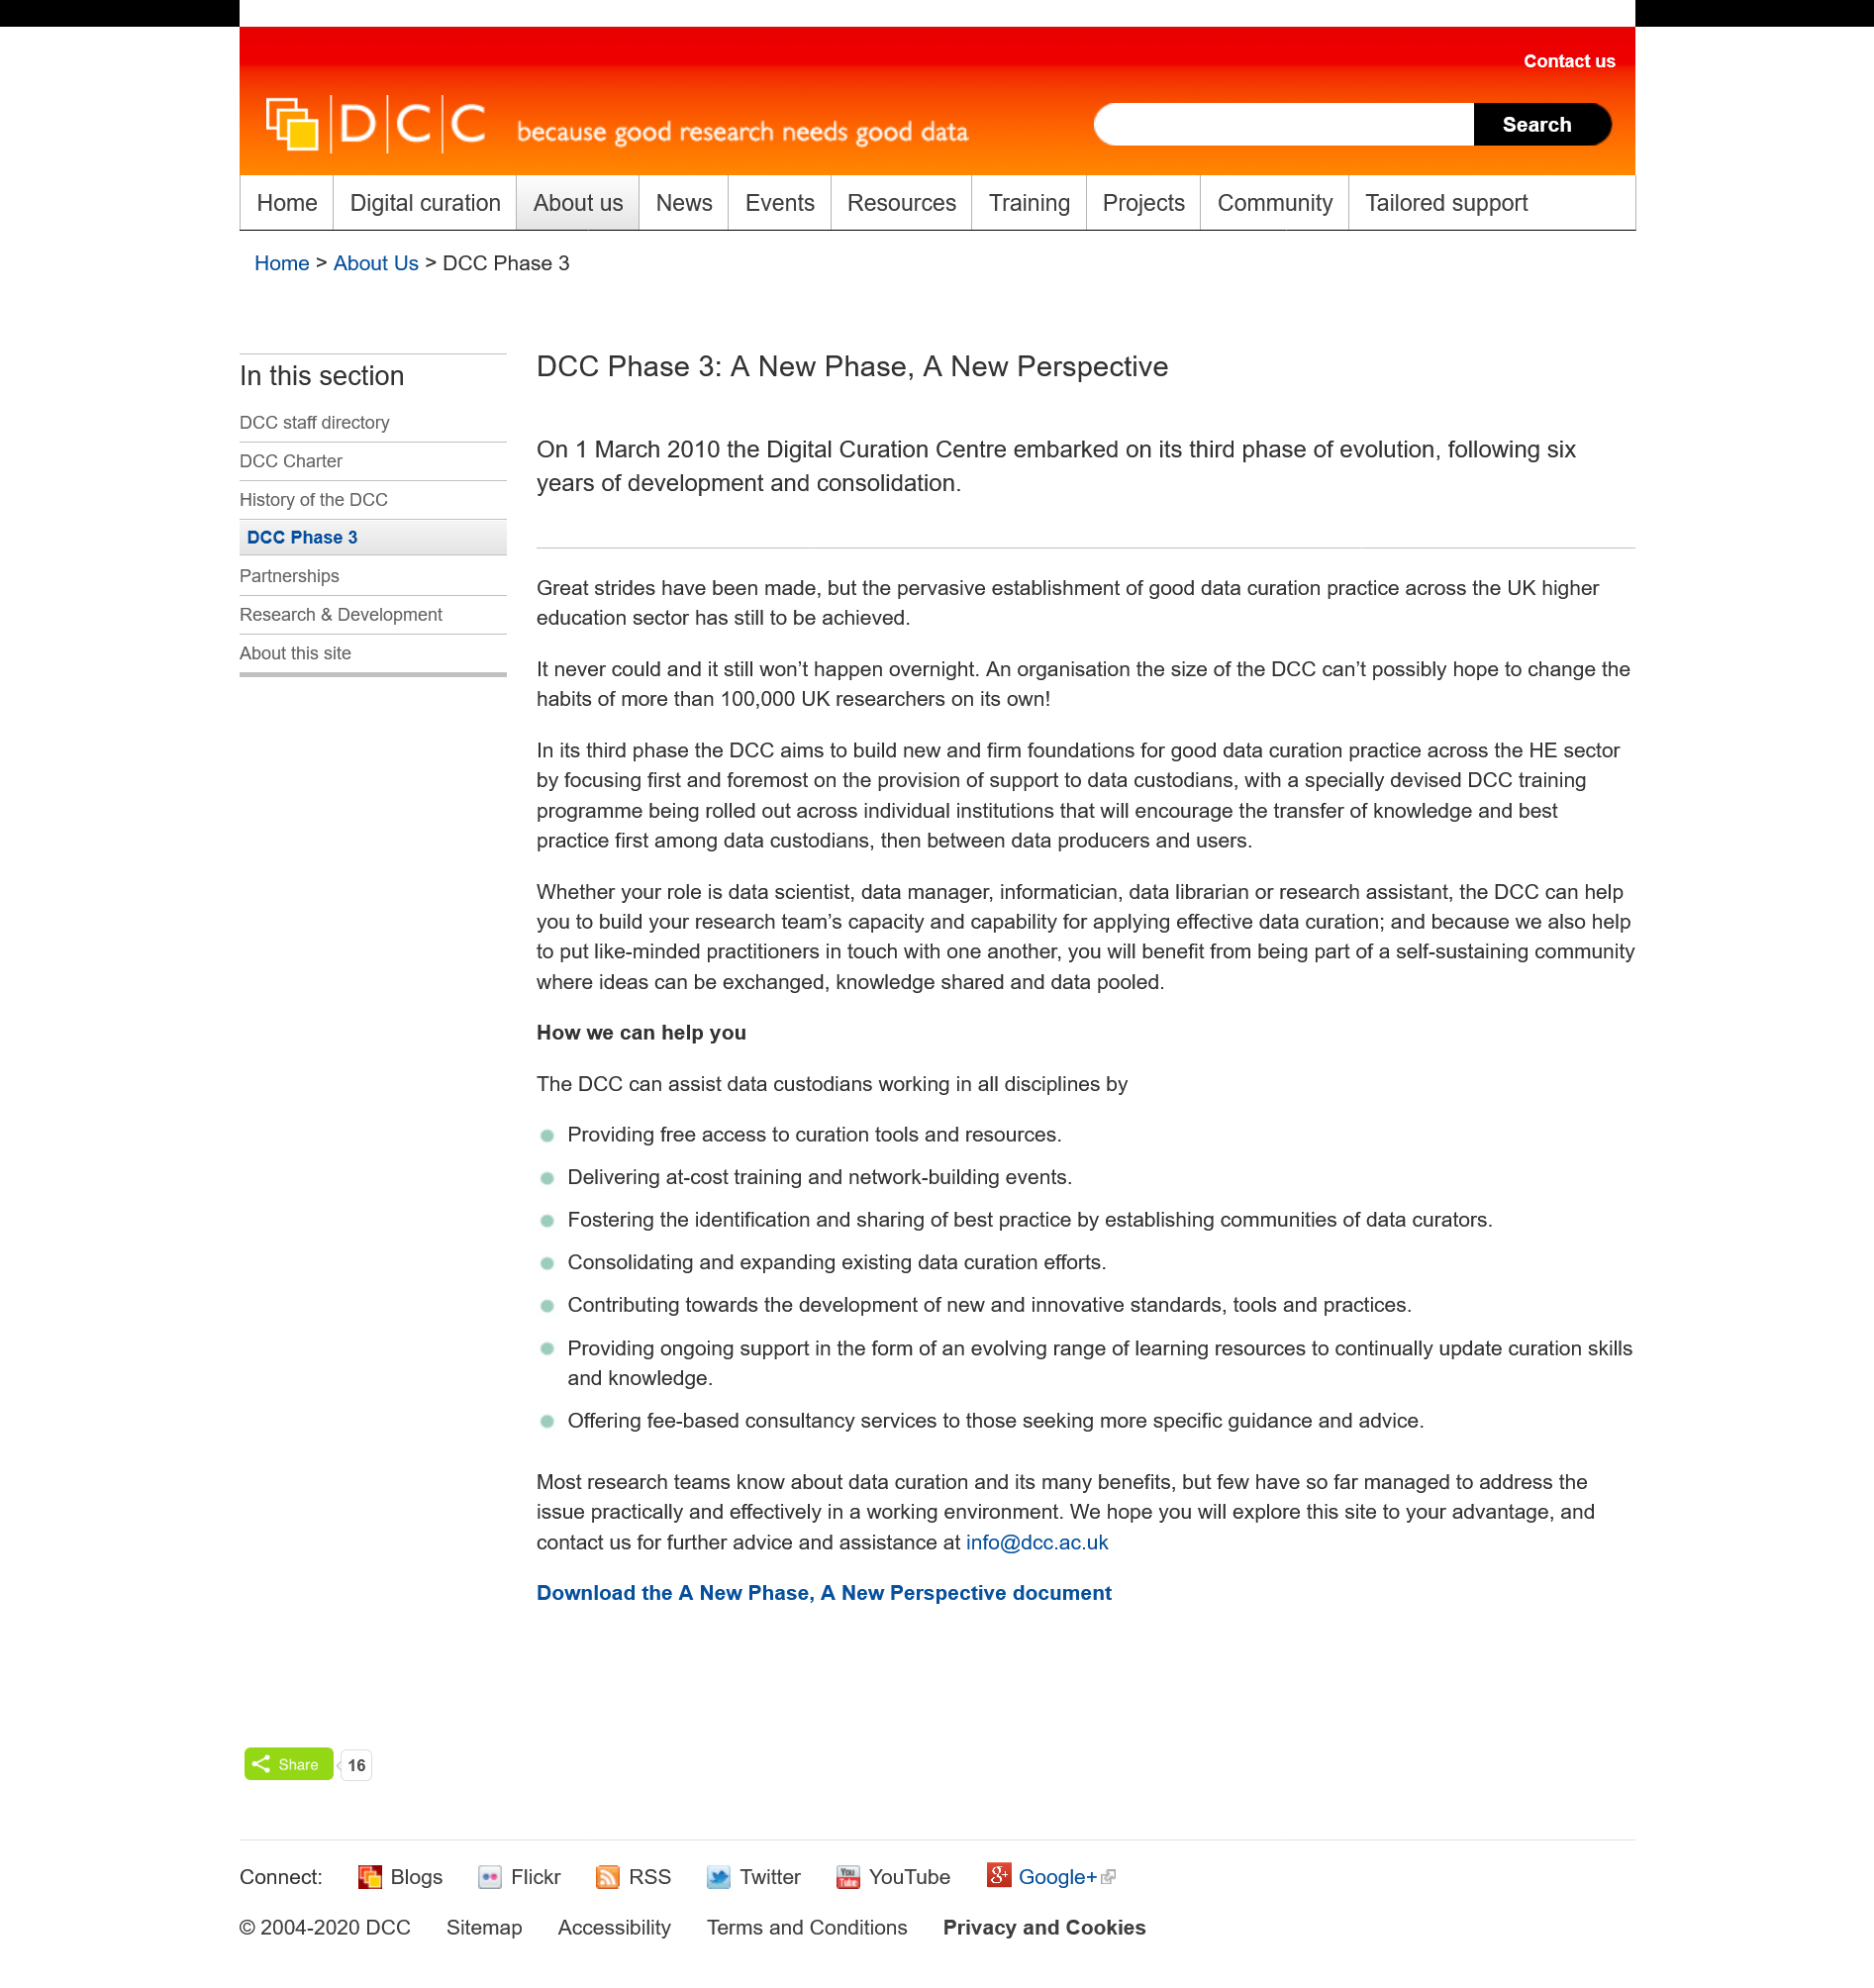Give some essential details in this illustration. The acronym "DCC" stands for "Digital Curation Centre. The Digital Curation Centre (DCC) is focused on supporting the higher education sector in the realm of digital curation. The DCC entered its third phase of evolution on March 1st, 2010. 